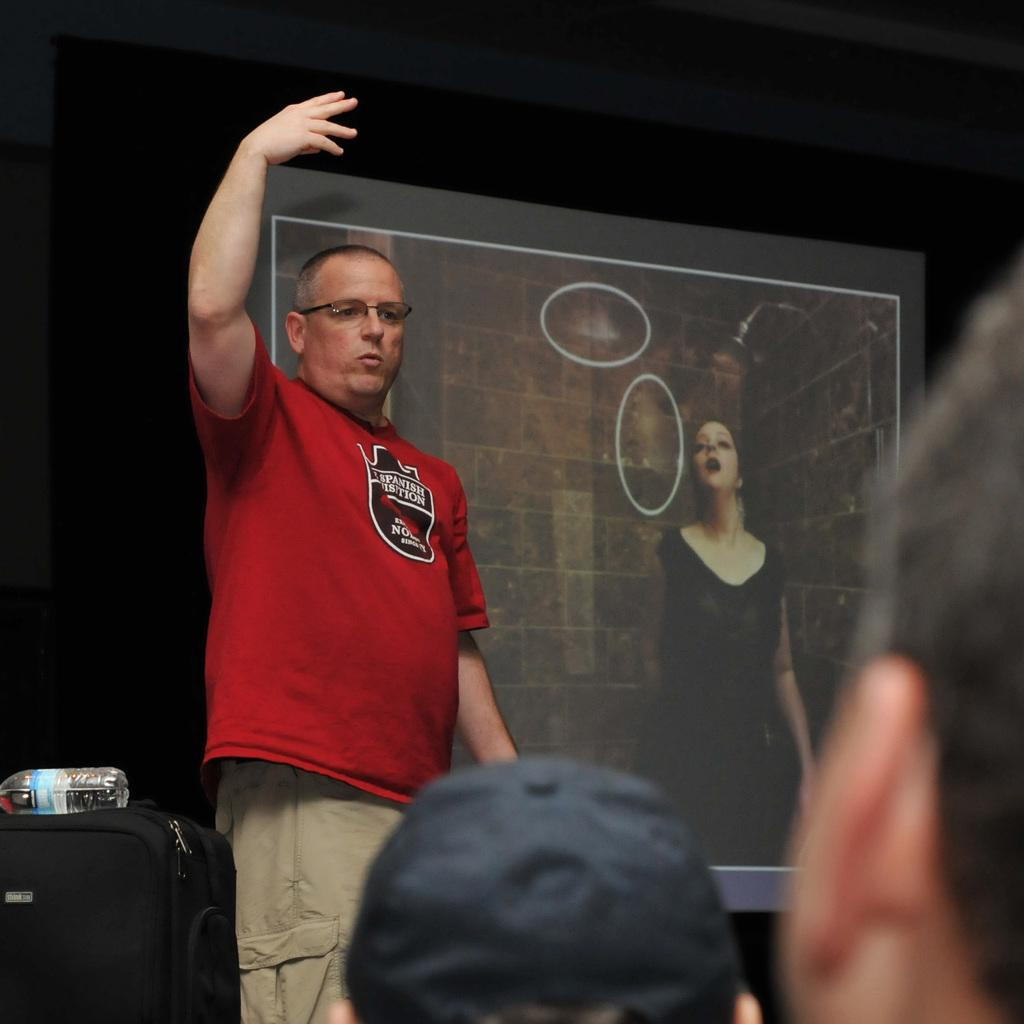What is on the wall in the image? There is a screen on the wall. What is happening on the screen? A woman is standing on the screen. What can be seen in front of the screen? There is a man standing in front of the screen. What is the man wearing? The man is wearing a red t-shirt. What other objects are present in the image? There is a luggage and a bottle on the luggage. How many mice are crawling on the man's face in the image? There are no mice present in the image, and the man's face is not visible. What type of plough is being used to till the ground in the image? There is no plough present in the image; it features a screen with a woman standing on it and a man wearing a red t-shirt. 